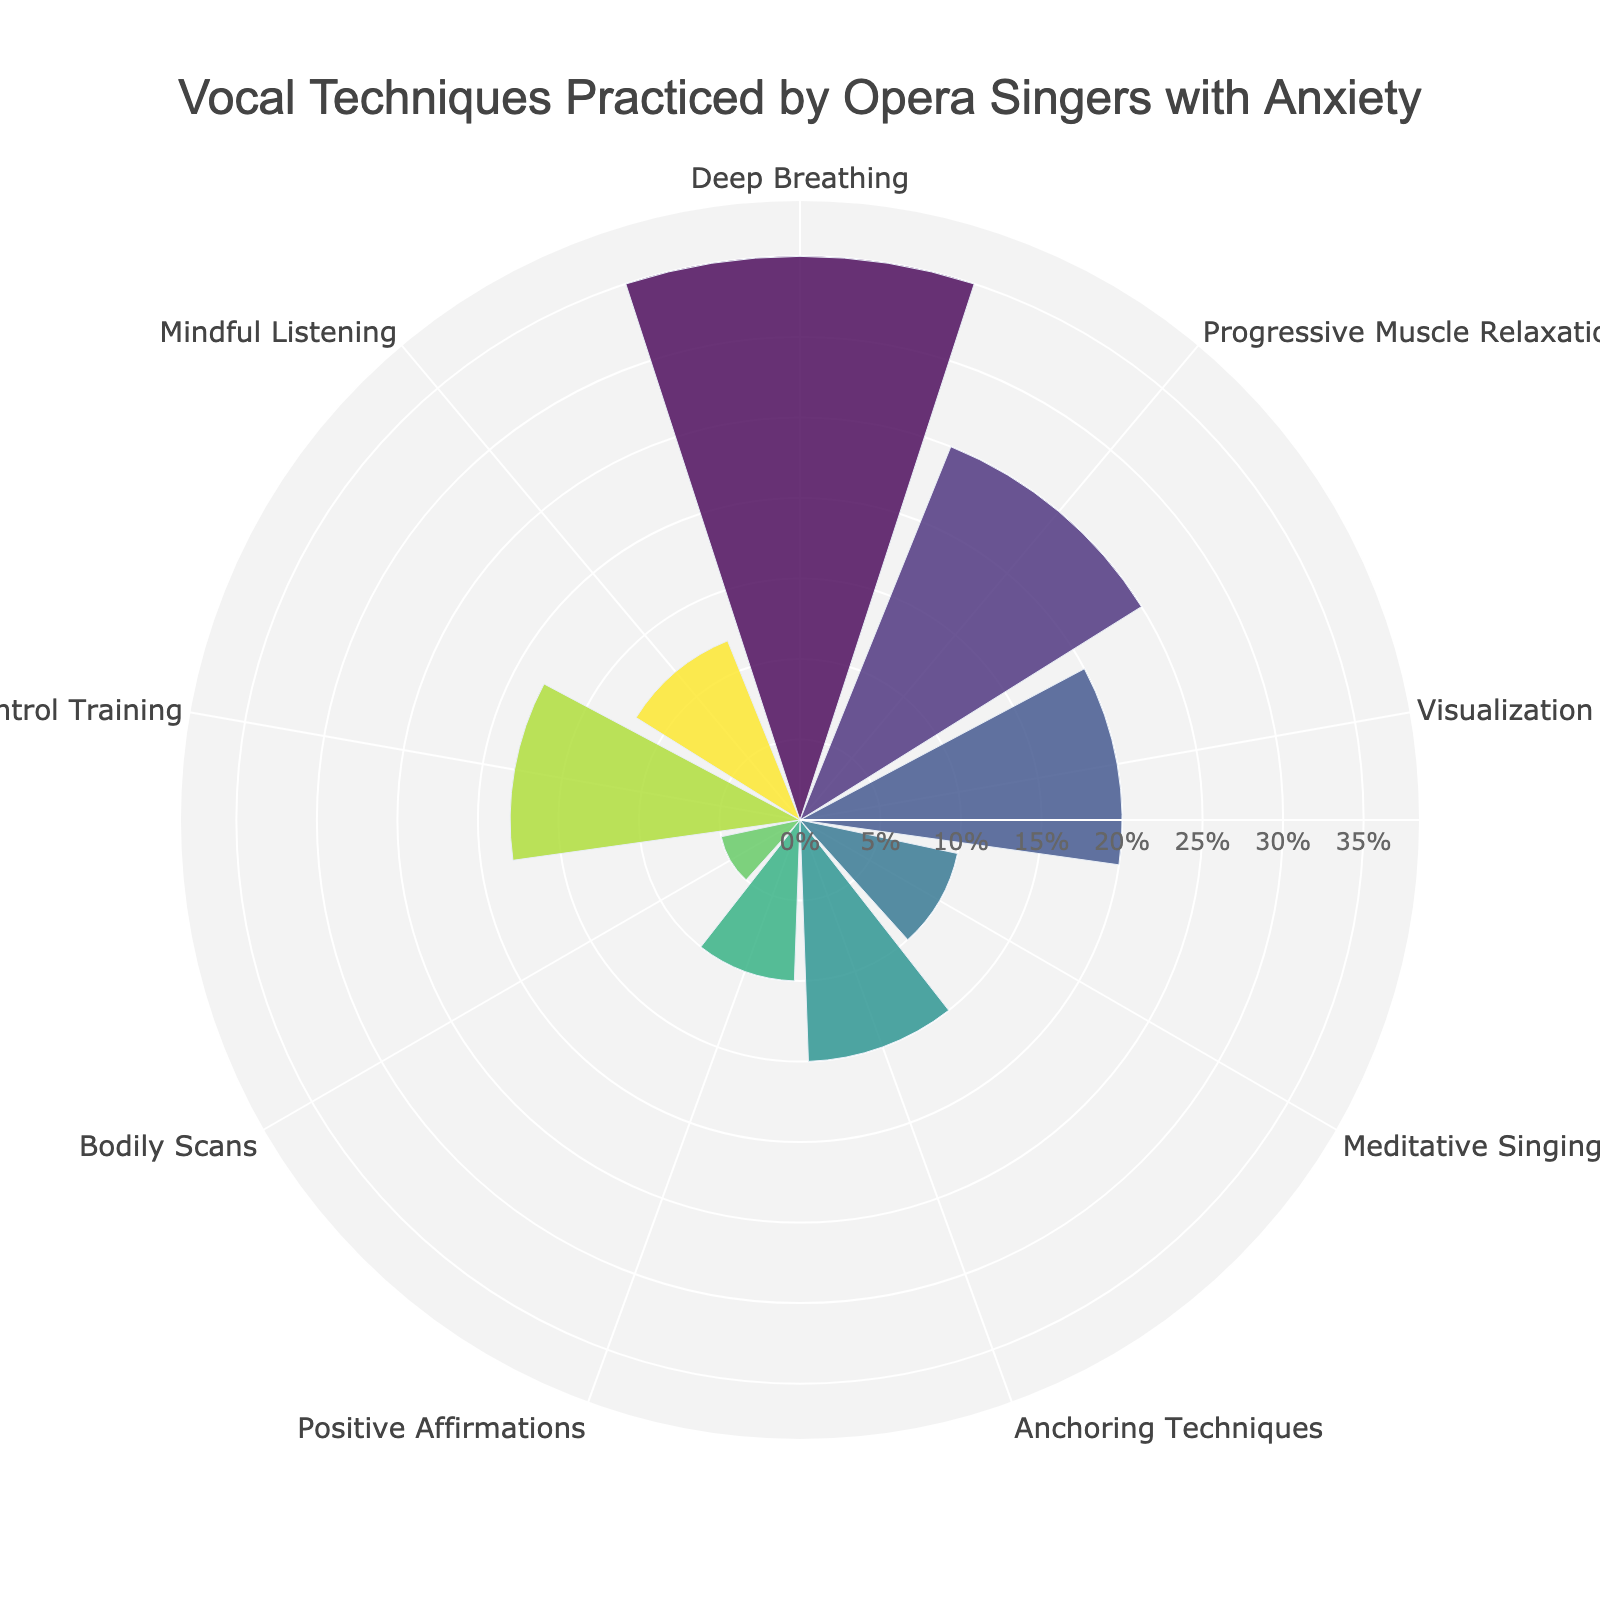Which technique has the highest percentage? The bar with the longest radial distance represents the highest percentage, which belongs to Deep Breathing.
Answer: Deep Breathing How many techniques are displayed on the chart? Count the number of labeled angles around the polar plot. There are 9 labeled angles.
Answer: 9 What is the combined percentage of Visualization and Meditative Singing? Sum the percentages for Visualization (20%) and Meditative Singing (10%).
Answer: 30% Which technique has a lower percentage than Anchoring Techniques but higher than Meditative Singing? Anchoring Techniques has 15%, and Meditative Singing has 10%. Attentional Control Training, with 18%, falls within this range.
Answer: Attentional Control Training What is the total percentage for all techniques combined? Sum all the percentages provided: 35 + 25 + 20 + 10 + 15 + 10 + 5 + 18 + 12 = 150.
Answer: 150% Which technique uses the fifth color in the color scale? Identify the fifth radial bar from the starting point, which corresponds to Anchoring Techniques.
Answer: Anchoring Techniques Compare the percentage of Bodily Scans to Mindful Listening. Which is higher? Bodily Scans have 5%, and Mindful Listening has 12%. Mindful Listening is higher.
Answer: Mindful Listening What is the average percentage of the techniques practiced? Calculate the average by summing all percentages and dividing by the number of techniques: (35 + 25 + 20 + 10 + 15 + 10 + 5 + 18 + 12) / 9.
Answer: 16.67% Which technique practiced by opera singers has a percentage under 10%? Identify bars with radial lengths under 10%, which are Meditative Singing, Positive Affirmations, and Bodily Scans.
Answer: Meditative Singing, Positive Affirmations, Bodily Scans 